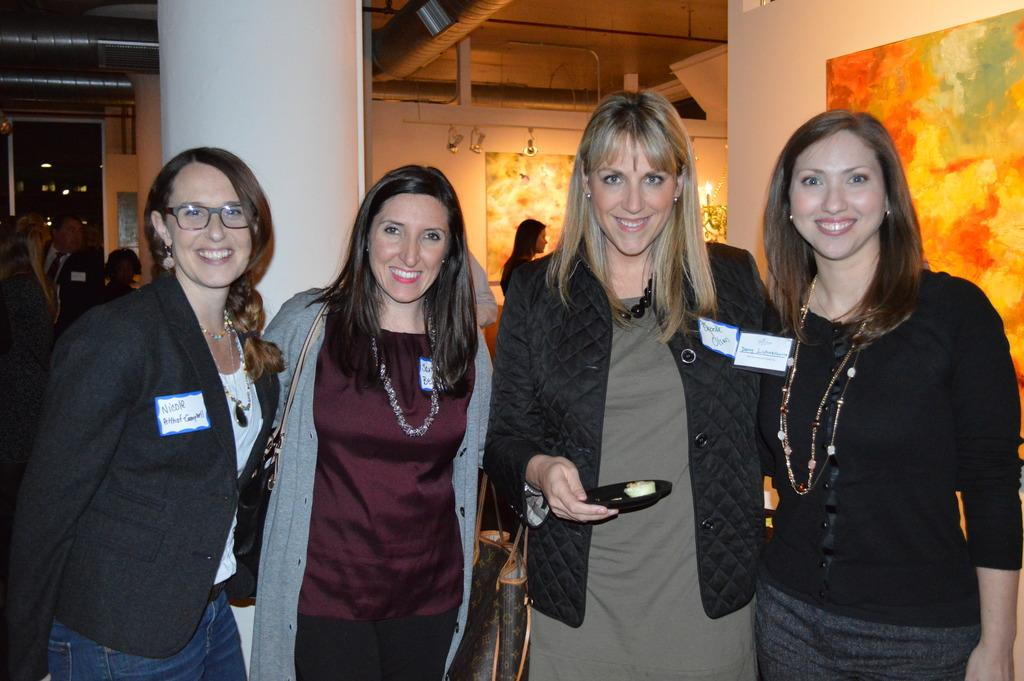What is happening in the image? There are people standing in the image. Can you describe what the woman is holding? The woman is holding a plate with food in her hand. What can be seen illuminating the scene? There are lights visible in the image. What type of decoration is present on the walls? Paintings are present on the walls. What type of harmony is being played by the lamp in the image? There is no lamp present in the image, and therefore no music or harmony can be heard. 